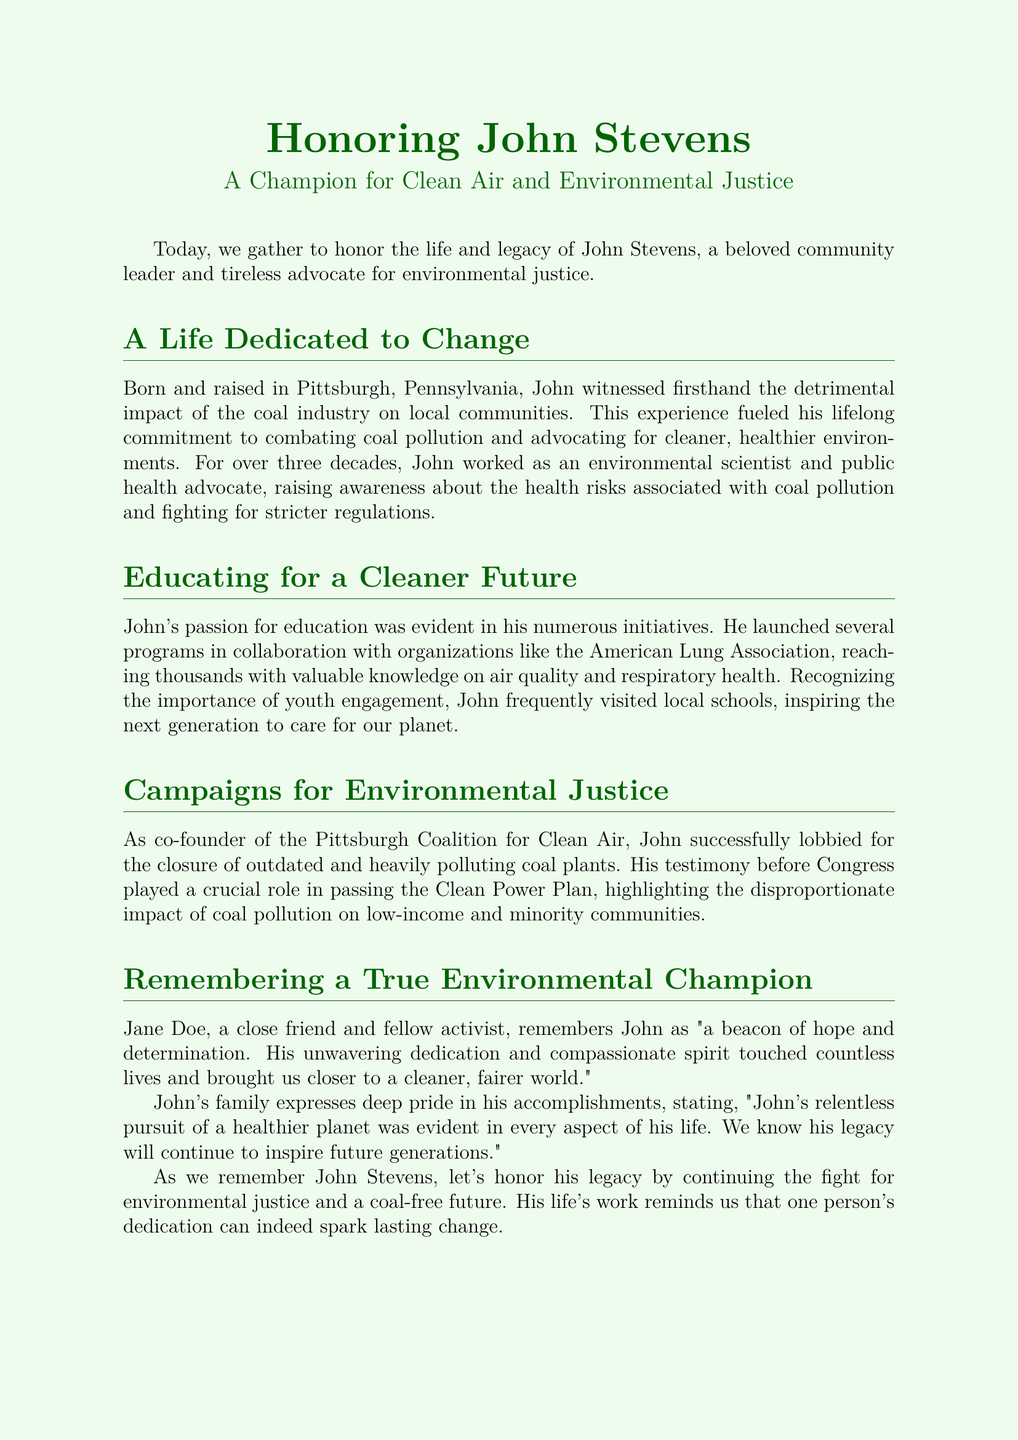What is the name of the community leader being honored? The document centers around John Stevens, who is celebrated for his work in environmental justice.
Answer: John Stevens What organization did John collaborate with to educate the public? The American Lung Association is mentioned as a partner in John’s initiatives for raising awareness on air quality.
Answer: American Lung Association How many years did John work as an environmental scientist and public health advocate? The document states that John worked in these roles for over three decades, indicating a long commitment to these causes.
Answer: Over three decades What significant environmental legislation did John help influence? John's testimony played a crucial role in the passage of the Clean Power Plan according to the document.
Answer: Clean Power Plan Who described John as "a beacon of hope and determination"? The document cites Jane Doe as a close friend and fellow activist who provided this description of John.
Answer: Jane Doe What group did John co-found that focused on pollution issues? John co-founded the Pittsburgh Coalition for Clean Air, which targeted air pollution from coal plants.
Answer: Pittsburgh Coalition for Clean Air What was one of John’s focuses in education? John emphasized the importance of engaging with local schools to inspire youth about caring for the planet.
Answer: Youth engagement What was John's family proud of regarding his work? His family expressed pride in John’s relentless pursuit of a healthier planet as part of his legacy.
Answer: Relentless pursuit of a healthier planet 